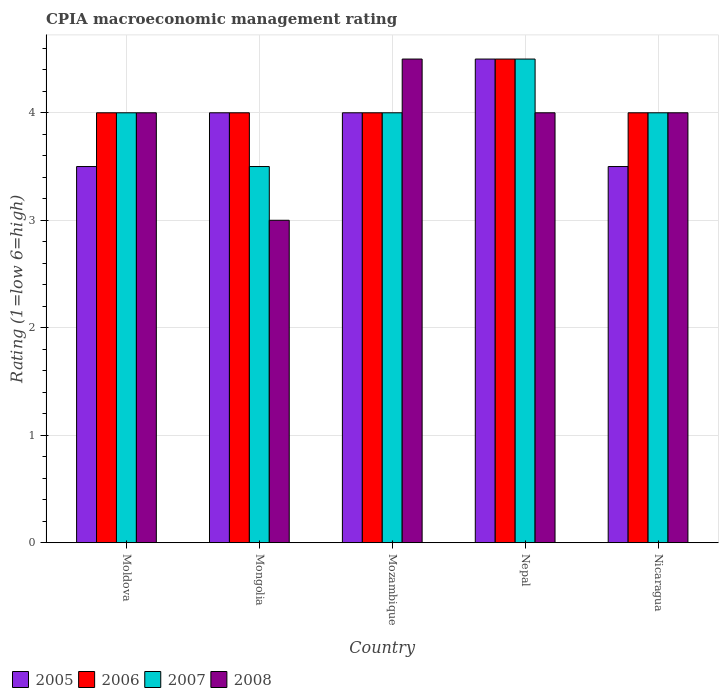How many groups of bars are there?
Provide a short and direct response. 5. Are the number of bars per tick equal to the number of legend labels?
Your answer should be compact. Yes. How many bars are there on the 3rd tick from the left?
Ensure brevity in your answer.  4. What is the label of the 1st group of bars from the left?
Keep it short and to the point. Moldova. In how many cases, is the number of bars for a given country not equal to the number of legend labels?
Offer a very short reply. 0. What is the CPIA rating in 2007 in Moldova?
Your answer should be very brief. 4. In which country was the CPIA rating in 2007 maximum?
Provide a succinct answer. Nepal. In which country was the CPIA rating in 2006 minimum?
Give a very brief answer. Moldova. What is the difference between the CPIA rating in 2008 in Moldova and the CPIA rating in 2007 in Mozambique?
Give a very brief answer. 0. What is the average CPIA rating in 2008 per country?
Provide a succinct answer. 3.9. What is the difference between the CPIA rating of/in 2008 and CPIA rating of/in 2005 in Mongolia?
Offer a very short reply. -1. What is the ratio of the CPIA rating in 2006 in Mongolia to that in Nicaragua?
Offer a terse response. 1. Is the CPIA rating in 2005 in Moldova less than that in Mozambique?
Your answer should be very brief. Yes. In how many countries, is the CPIA rating in 2007 greater than the average CPIA rating in 2007 taken over all countries?
Ensure brevity in your answer.  1. What does the 1st bar from the left in Mongolia represents?
Your answer should be very brief. 2005. What does the 1st bar from the right in Nepal represents?
Your answer should be compact. 2008. Is it the case that in every country, the sum of the CPIA rating in 2008 and CPIA rating in 2005 is greater than the CPIA rating in 2006?
Keep it short and to the point. Yes. Are all the bars in the graph horizontal?
Your response must be concise. No. What is the difference between two consecutive major ticks on the Y-axis?
Offer a terse response. 1. Are the values on the major ticks of Y-axis written in scientific E-notation?
Your answer should be very brief. No. How many legend labels are there?
Make the answer very short. 4. How are the legend labels stacked?
Offer a terse response. Horizontal. What is the title of the graph?
Your answer should be very brief. CPIA macroeconomic management rating. Does "1982" appear as one of the legend labels in the graph?
Keep it short and to the point. No. What is the label or title of the X-axis?
Provide a succinct answer. Country. What is the Rating (1=low 6=high) of 2005 in Moldova?
Your response must be concise. 3.5. What is the Rating (1=low 6=high) in 2005 in Mongolia?
Give a very brief answer. 4. What is the Rating (1=low 6=high) in 2006 in Mongolia?
Ensure brevity in your answer.  4. What is the Rating (1=low 6=high) of 2006 in Mozambique?
Keep it short and to the point. 4. What is the Rating (1=low 6=high) in 2007 in Mozambique?
Provide a succinct answer. 4. What is the Rating (1=low 6=high) of 2006 in Nepal?
Offer a terse response. 4.5. What is the Rating (1=low 6=high) in 2007 in Nepal?
Provide a succinct answer. 4.5. What is the Rating (1=low 6=high) in 2005 in Nicaragua?
Make the answer very short. 3.5. What is the Rating (1=low 6=high) of 2006 in Nicaragua?
Offer a terse response. 4. What is the Rating (1=low 6=high) of 2007 in Nicaragua?
Your response must be concise. 4. Across all countries, what is the maximum Rating (1=low 6=high) in 2006?
Your response must be concise. 4.5. Across all countries, what is the maximum Rating (1=low 6=high) in 2008?
Keep it short and to the point. 4.5. Across all countries, what is the minimum Rating (1=low 6=high) in 2008?
Provide a short and direct response. 3. What is the total Rating (1=low 6=high) of 2007 in the graph?
Offer a terse response. 20. What is the total Rating (1=low 6=high) in 2008 in the graph?
Your response must be concise. 19.5. What is the difference between the Rating (1=low 6=high) of 2005 in Moldova and that in Mongolia?
Your answer should be compact. -0.5. What is the difference between the Rating (1=low 6=high) of 2006 in Moldova and that in Mongolia?
Keep it short and to the point. 0. What is the difference between the Rating (1=low 6=high) of 2007 in Moldova and that in Mozambique?
Your response must be concise. 0. What is the difference between the Rating (1=low 6=high) in 2008 in Moldova and that in Mozambique?
Provide a short and direct response. -0.5. What is the difference between the Rating (1=low 6=high) in 2005 in Moldova and that in Nepal?
Offer a terse response. -1. What is the difference between the Rating (1=low 6=high) of 2007 in Moldova and that in Nicaragua?
Provide a short and direct response. 0. What is the difference between the Rating (1=low 6=high) of 2005 in Mongolia and that in Mozambique?
Provide a short and direct response. 0. What is the difference between the Rating (1=low 6=high) of 2006 in Mongolia and that in Mozambique?
Offer a very short reply. 0. What is the difference between the Rating (1=low 6=high) in 2007 in Mongolia and that in Mozambique?
Your answer should be compact. -0.5. What is the difference between the Rating (1=low 6=high) of 2008 in Mongolia and that in Mozambique?
Offer a terse response. -1.5. What is the difference between the Rating (1=low 6=high) of 2006 in Mongolia and that in Nepal?
Your response must be concise. -0.5. What is the difference between the Rating (1=low 6=high) of 2007 in Mongolia and that in Nepal?
Keep it short and to the point. -1. What is the difference between the Rating (1=low 6=high) of 2007 in Mongolia and that in Nicaragua?
Give a very brief answer. -0.5. What is the difference between the Rating (1=low 6=high) in 2005 in Mozambique and that in Nepal?
Provide a short and direct response. -0.5. What is the difference between the Rating (1=low 6=high) of 2006 in Mozambique and that in Nepal?
Your answer should be compact. -0.5. What is the difference between the Rating (1=low 6=high) in 2007 in Mozambique and that in Nepal?
Your answer should be compact. -0.5. What is the difference between the Rating (1=low 6=high) in 2008 in Mozambique and that in Nepal?
Your answer should be very brief. 0.5. What is the difference between the Rating (1=low 6=high) of 2008 in Mozambique and that in Nicaragua?
Ensure brevity in your answer.  0.5. What is the difference between the Rating (1=low 6=high) of 2005 in Nepal and that in Nicaragua?
Provide a short and direct response. 1. What is the difference between the Rating (1=low 6=high) of 2007 in Nepal and that in Nicaragua?
Your answer should be compact. 0.5. What is the difference between the Rating (1=low 6=high) in 2008 in Nepal and that in Nicaragua?
Offer a terse response. 0. What is the difference between the Rating (1=low 6=high) of 2005 in Moldova and the Rating (1=low 6=high) of 2006 in Mongolia?
Offer a very short reply. -0.5. What is the difference between the Rating (1=low 6=high) in 2006 in Moldova and the Rating (1=low 6=high) in 2008 in Mongolia?
Give a very brief answer. 1. What is the difference between the Rating (1=low 6=high) in 2005 in Moldova and the Rating (1=low 6=high) in 2006 in Nepal?
Your response must be concise. -1. What is the difference between the Rating (1=low 6=high) in 2005 in Moldova and the Rating (1=low 6=high) in 2008 in Nepal?
Your response must be concise. -0.5. What is the difference between the Rating (1=low 6=high) of 2006 in Moldova and the Rating (1=low 6=high) of 2008 in Nepal?
Offer a terse response. 0. What is the difference between the Rating (1=low 6=high) in 2005 in Moldova and the Rating (1=low 6=high) in 2006 in Nicaragua?
Ensure brevity in your answer.  -0.5. What is the difference between the Rating (1=low 6=high) in 2005 in Moldova and the Rating (1=low 6=high) in 2008 in Nicaragua?
Your answer should be compact. -0.5. What is the difference between the Rating (1=low 6=high) in 2007 in Moldova and the Rating (1=low 6=high) in 2008 in Nicaragua?
Give a very brief answer. 0. What is the difference between the Rating (1=low 6=high) of 2005 in Mongolia and the Rating (1=low 6=high) of 2006 in Mozambique?
Your response must be concise. 0. What is the difference between the Rating (1=low 6=high) in 2007 in Mongolia and the Rating (1=low 6=high) in 2008 in Mozambique?
Provide a short and direct response. -1. What is the difference between the Rating (1=low 6=high) in 2005 in Mongolia and the Rating (1=low 6=high) in 2006 in Nepal?
Keep it short and to the point. -0.5. What is the difference between the Rating (1=low 6=high) of 2005 in Mongolia and the Rating (1=low 6=high) of 2008 in Nepal?
Offer a very short reply. 0. What is the difference between the Rating (1=low 6=high) in 2006 in Mongolia and the Rating (1=low 6=high) in 2007 in Nepal?
Your answer should be compact. -0.5. What is the difference between the Rating (1=low 6=high) in 2005 in Mongolia and the Rating (1=low 6=high) in 2006 in Nicaragua?
Make the answer very short. 0. What is the difference between the Rating (1=low 6=high) in 2005 in Mongolia and the Rating (1=low 6=high) in 2007 in Nicaragua?
Offer a very short reply. 0. What is the difference between the Rating (1=low 6=high) in 2006 in Mongolia and the Rating (1=low 6=high) in 2008 in Nicaragua?
Your answer should be very brief. 0. What is the difference between the Rating (1=low 6=high) in 2006 in Mozambique and the Rating (1=low 6=high) in 2007 in Nepal?
Offer a terse response. -0.5. What is the difference between the Rating (1=low 6=high) of 2006 in Mozambique and the Rating (1=low 6=high) of 2008 in Nepal?
Give a very brief answer. 0. What is the difference between the Rating (1=low 6=high) of 2007 in Mozambique and the Rating (1=low 6=high) of 2008 in Nepal?
Your answer should be very brief. 0. What is the difference between the Rating (1=low 6=high) in 2005 in Mozambique and the Rating (1=low 6=high) in 2007 in Nicaragua?
Ensure brevity in your answer.  0. What is the difference between the Rating (1=low 6=high) in 2005 in Nepal and the Rating (1=low 6=high) in 2007 in Nicaragua?
Offer a very short reply. 0.5. What is the difference between the Rating (1=low 6=high) in 2007 in Nepal and the Rating (1=low 6=high) in 2008 in Nicaragua?
Make the answer very short. 0.5. What is the average Rating (1=low 6=high) of 2007 per country?
Provide a succinct answer. 4. What is the average Rating (1=low 6=high) of 2008 per country?
Your answer should be very brief. 3.9. What is the difference between the Rating (1=low 6=high) of 2005 and Rating (1=low 6=high) of 2006 in Moldova?
Your answer should be compact. -0.5. What is the difference between the Rating (1=low 6=high) of 2005 and Rating (1=low 6=high) of 2007 in Moldova?
Ensure brevity in your answer.  -0.5. What is the difference between the Rating (1=low 6=high) of 2006 and Rating (1=low 6=high) of 2007 in Moldova?
Your answer should be very brief. 0. What is the difference between the Rating (1=low 6=high) in 2006 and Rating (1=low 6=high) in 2008 in Moldova?
Your answer should be compact. 0. What is the difference between the Rating (1=low 6=high) of 2007 and Rating (1=low 6=high) of 2008 in Moldova?
Your answer should be very brief. 0. What is the difference between the Rating (1=low 6=high) in 2005 and Rating (1=low 6=high) in 2006 in Mongolia?
Your answer should be compact. 0. What is the difference between the Rating (1=low 6=high) in 2006 and Rating (1=low 6=high) in 2007 in Mongolia?
Provide a short and direct response. 0.5. What is the difference between the Rating (1=low 6=high) in 2006 and Rating (1=low 6=high) in 2008 in Mongolia?
Make the answer very short. 1. What is the difference between the Rating (1=low 6=high) in 2005 and Rating (1=low 6=high) in 2006 in Mozambique?
Ensure brevity in your answer.  0. What is the difference between the Rating (1=low 6=high) in 2005 and Rating (1=low 6=high) in 2007 in Mozambique?
Provide a succinct answer. 0. What is the difference between the Rating (1=low 6=high) of 2005 and Rating (1=low 6=high) of 2008 in Mozambique?
Provide a short and direct response. -0.5. What is the difference between the Rating (1=low 6=high) of 2006 and Rating (1=low 6=high) of 2007 in Mozambique?
Offer a very short reply. 0. What is the difference between the Rating (1=low 6=high) in 2005 and Rating (1=low 6=high) in 2006 in Nepal?
Your answer should be very brief. 0. What is the difference between the Rating (1=low 6=high) of 2005 and Rating (1=low 6=high) of 2008 in Nepal?
Keep it short and to the point. 0.5. What is the difference between the Rating (1=low 6=high) of 2007 and Rating (1=low 6=high) of 2008 in Nepal?
Provide a succinct answer. 0.5. What is the difference between the Rating (1=low 6=high) of 2005 and Rating (1=low 6=high) of 2007 in Nicaragua?
Provide a short and direct response. -0.5. What is the difference between the Rating (1=low 6=high) of 2007 and Rating (1=low 6=high) of 2008 in Nicaragua?
Your answer should be very brief. 0. What is the ratio of the Rating (1=low 6=high) in 2006 in Moldova to that in Mongolia?
Your answer should be very brief. 1. What is the ratio of the Rating (1=low 6=high) in 2006 in Moldova to that in Mozambique?
Offer a very short reply. 1. What is the ratio of the Rating (1=low 6=high) of 2007 in Moldova to that in Mozambique?
Offer a terse response. 1. What is the ratio of the Rating (1=low 6=high) of 2005 in Moldova to that in Nepal?
Offer a terse response. 0.78. What is the ratio of the Rating (1=low 6=high) in 2006 in Moldova to that in Nepal?
Ensure brevity in your answer.  0.89. What is the ratio of the Rating (1=low 6=high) of 2008 in Moldova to that in Nepal?
Provide a succinct answer. 1. What is the ratio of the Rating (1=low 6=high) of 2005 in Moldova to that in Nicaragua?
Your answer should be very brief. 1. What is the ratio of the Rating (1=low 6=high) of 2008 in Moldova to that in Nicaragua?
Your response must be concise. 1. What is the ratio of the Rating (1=low 6=high) in 2006 in Mongolia to that in Mozambique?
Make the answer very short. 1. What is the ratio of the Rating (1=low 6=high) of 2008 in Mongolia to that in Mozambique?
Ensure brevity in your answer.  0.67. What is the ratio of the Rating (1=low 6=high) in 2006 in Mongolia to that in Nepal?
Your answer should be compact. 0.89. What is the ratio of the Rating (1=low 6=high) of 2008 in Mongolia to that in Nepal?
Offer a very short reply. 0.75. What is the ratio of the Rating (1=low 6=high) of 2007 in Mongolia to that in Nicaragua?
Provide a succinct answer. 0.88. What is the ratio of the Rating (1=low 6=high) in 2008 in Mongolia to that in Nicaragua?
Your answer should be very brief. 0.75. What is the ratio of the Rating (1=low 6=high) of 2006 in Mozambique to that in Nepal?
Offer a very short reply. 0.89. What is the ratio of the Rating (1=low 6=high) in 2007 in Mozambique to that in Nepal?
Your answer should be very brief. 0.89. What is the ratio of the Rating (1=low 6=high) in 2005 in Mozambique to that in Nicaragua?
Provide a short and direct response. 1.14. What is the ratio of the Rating (1=low 6=high) of 2006 in Mozambique to that in Nicaragua?
Give a very brief answer. 1. What is the difference between the highest and the second highest Rating (1=low 6=high) of 2008?
Offer a very short reply. 0.5. What is the difference between the highest and the lowest Rating (1=low 6=high) of 2005?
Your answer should be very brief. 1. 